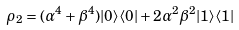Convert formula to latex. <formula><loc_0><loc_0><loc_500><loc_500>\rho _ { 2 } = ( \alpha ^ { 4 } + \beta ^ { 4 } ) | 0 \rangle \langle 0 | + 2 \alpha ^ { 2 } \beta ^ { 2 } | 1 \rangle \langle 1 |</formula> 